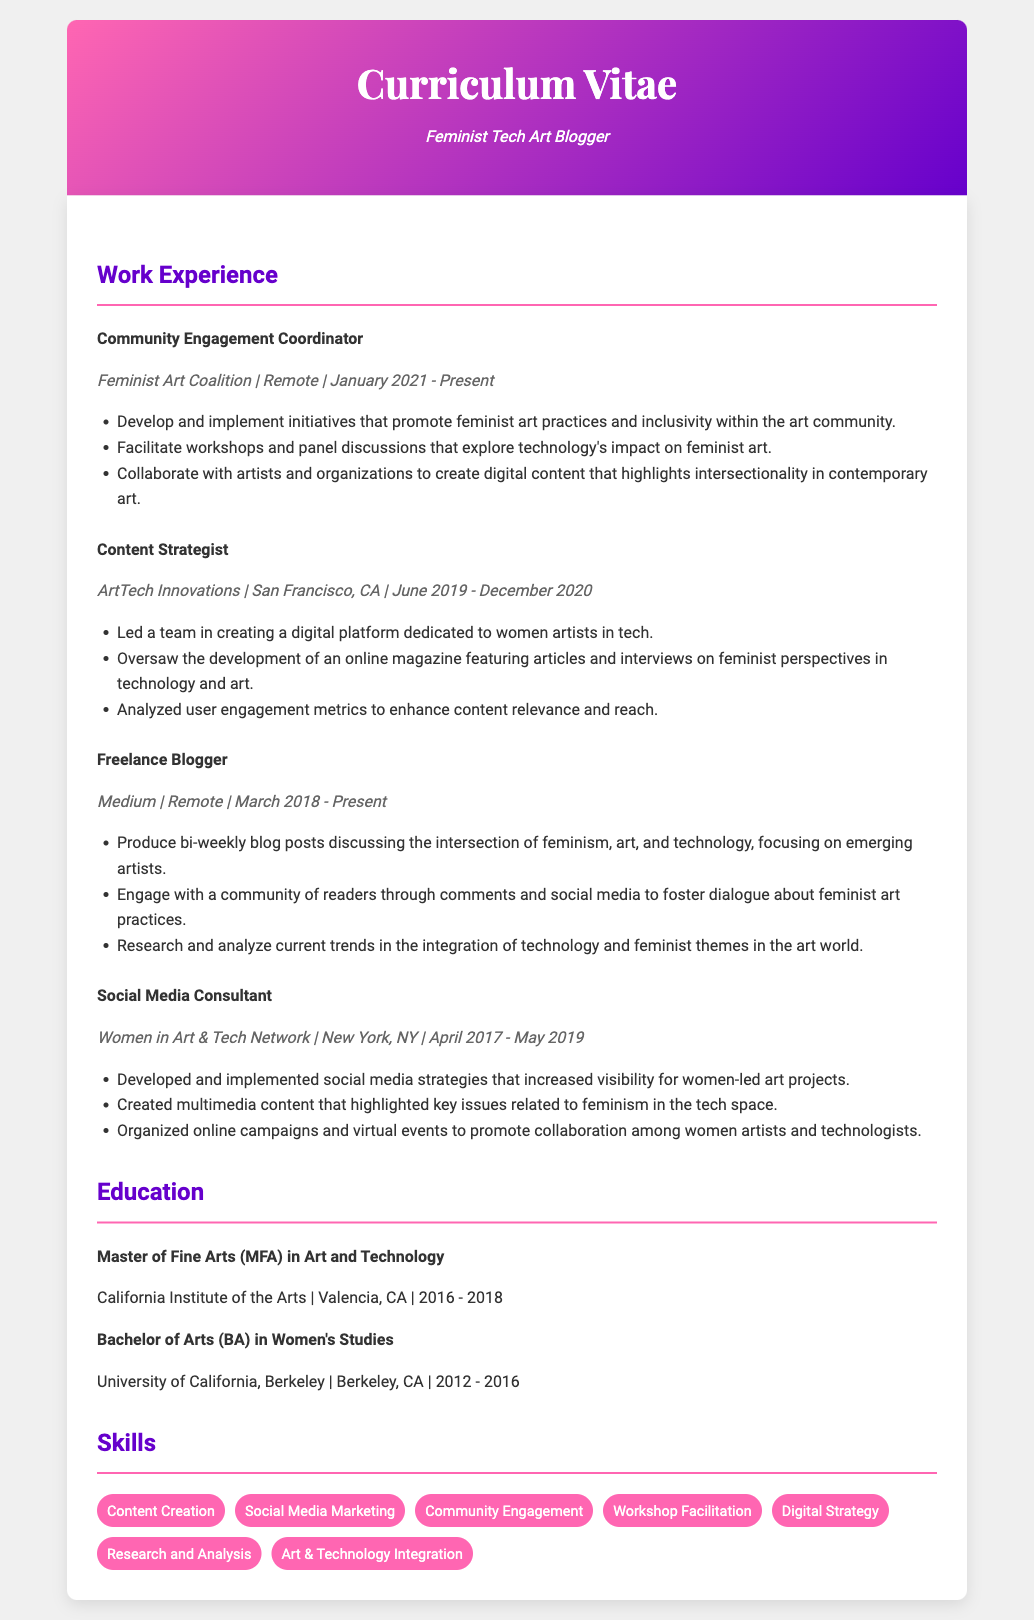What is the job title at Feminist Art Coalition? The job title is mentioned at the beginning of the respective entry under work experience.
Answer: Community Engagement Coordinator When did the Content Strategist position start at ArtTech Innovations? The start date for the Content Strategist position is specified in the job entry.
Answer: June 2019 How long has the Freelance Blogger position been held? The duration of the Freelance Blogger position is calculated from the start date to the present date mentioned in the document.
Answer: Over 5 years What core topic is focused on in the blog posts? The main topic of the blog is indicated in the job description for the Freelance Blogger.
Answer: Intersection of feminism, art, and technology What is one responsibility of the Community Engagement Coordinator? This responsibility is detailed within the respective job entry under work experience.
Answer: Develop and implement initiatives that promote feminist art practices and inclusivity How many years did the Social Media Consultant work? The duration is determined by the start and end dates provided in the job entry.
Answer: 2 years What degree was obtained at the California Institute of the Arts? The degree is clearly stated in the education section of the document.
Answer: Master of Fine Arts (MFA) in Art and Technology Which company is mentioned for the role of Social Media Consultant? The company name is directly cited in the job entry for that position.
Answer: Women in Art & Tech Network Which skill relates to researching trends in the document? The skill is explicitly highlighted in the skills section and relates to analysis duties.
Answer: Research and Analysis 